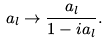<formula> <loc_0><loc_0><loc_500><loc_500>a _ { l } \rightarrow \frac { a _ { l } } { 1 - i a _ { l } } .</formula> 